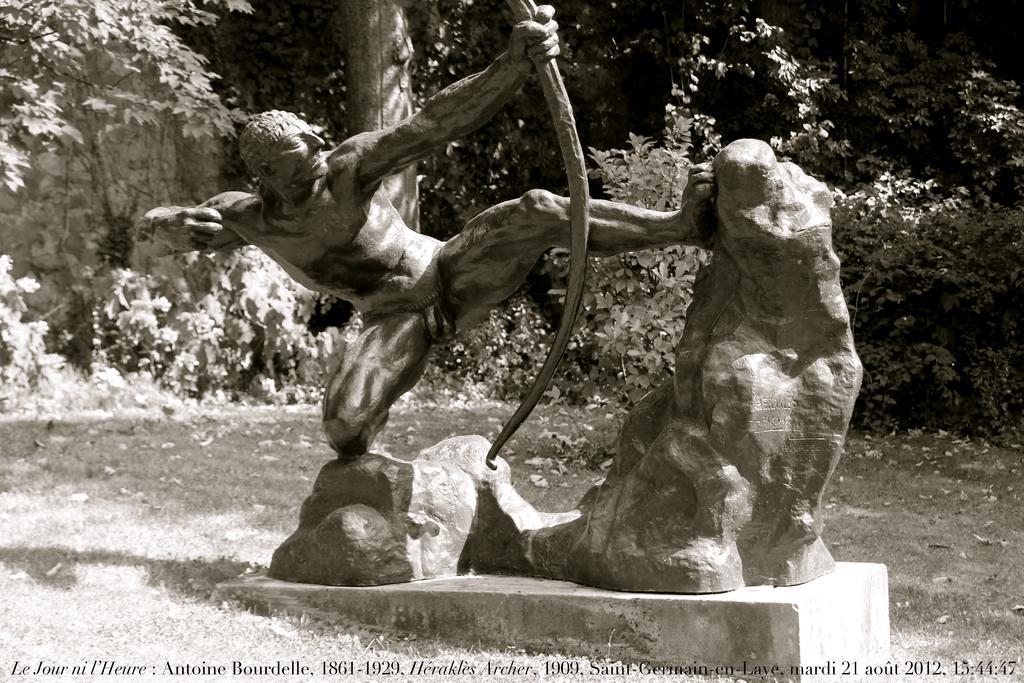Could you give a brief overview of what you see in this image? It is a black and white image, there is a sculpture and behind the sculpture there are many trees. 